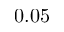Convert formula to latex. <formula><loc_0><loc_0><loc_500><loc_500>0 . 0 5</formula> 